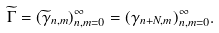Convert formula to latex. <formula><loc_0><loc_0><loc_500><loc_500>\widetilde { \Gamma } = ( \widetilde { \gamma } _ { n , m } ) _ { n , m = 0 } ^ { \infty } = ( \gamma _ { n + N , m } ) _ { n , m = 0 } ^ { \infty } .</formula> 